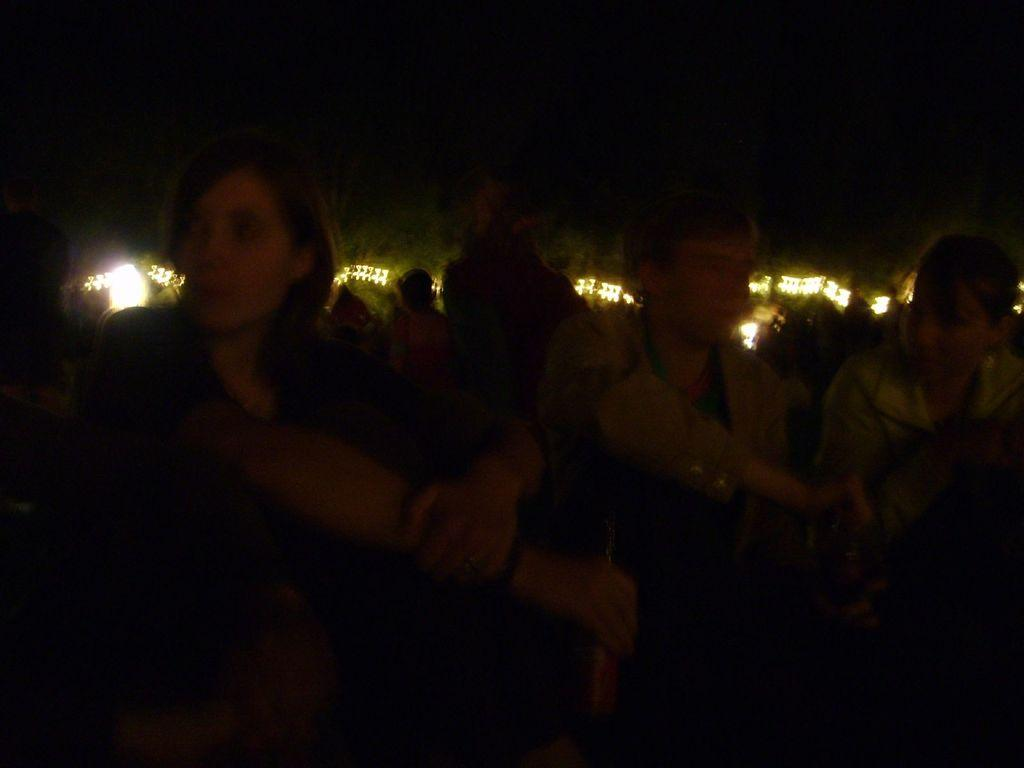How many people are in the image? There is a group of people in the image, but the exact number is not specified. What can be seen in the background of the image? There are trees and lights in the background of the image. How would you describe the lighting conditions in the image? The background of the image is dark. What type of error can be seen in the image? There is no error present in the image. Can you spot a deer in the image? There is no deer present in the image. 